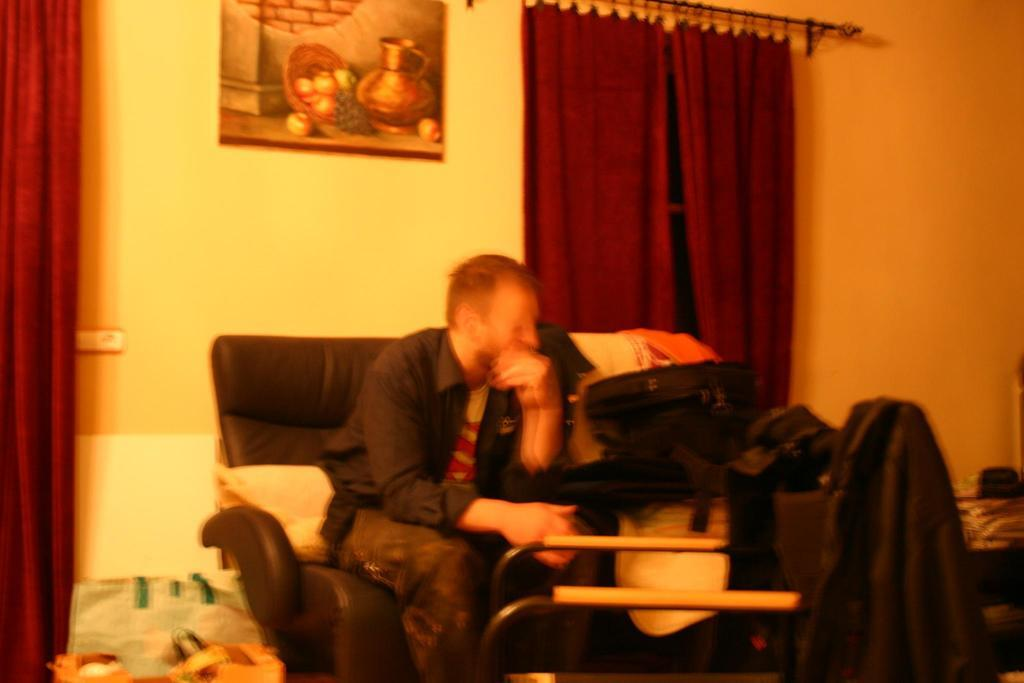What is the man in the image doing? The man is sitting on a chair in the image. What items can be seen in the image besides the man? There are bags, clothes, curtains, a frame on the wall, and other objects present in the image. Can you describe the bags in the image? The bags are visible in the image, but their specific contents or characteristics are not mentioned in the provided facts. What is the purpose of the frame on the wall in the image? The purpose of the frame on the wall is not mentioned in the provided facts, so it cannot be determined from the image. What type of breakfast is the man eating in the image? There is no breakfast present in the image; the man is sitting on a chair, and other items are visible, but no food is mentioned. 